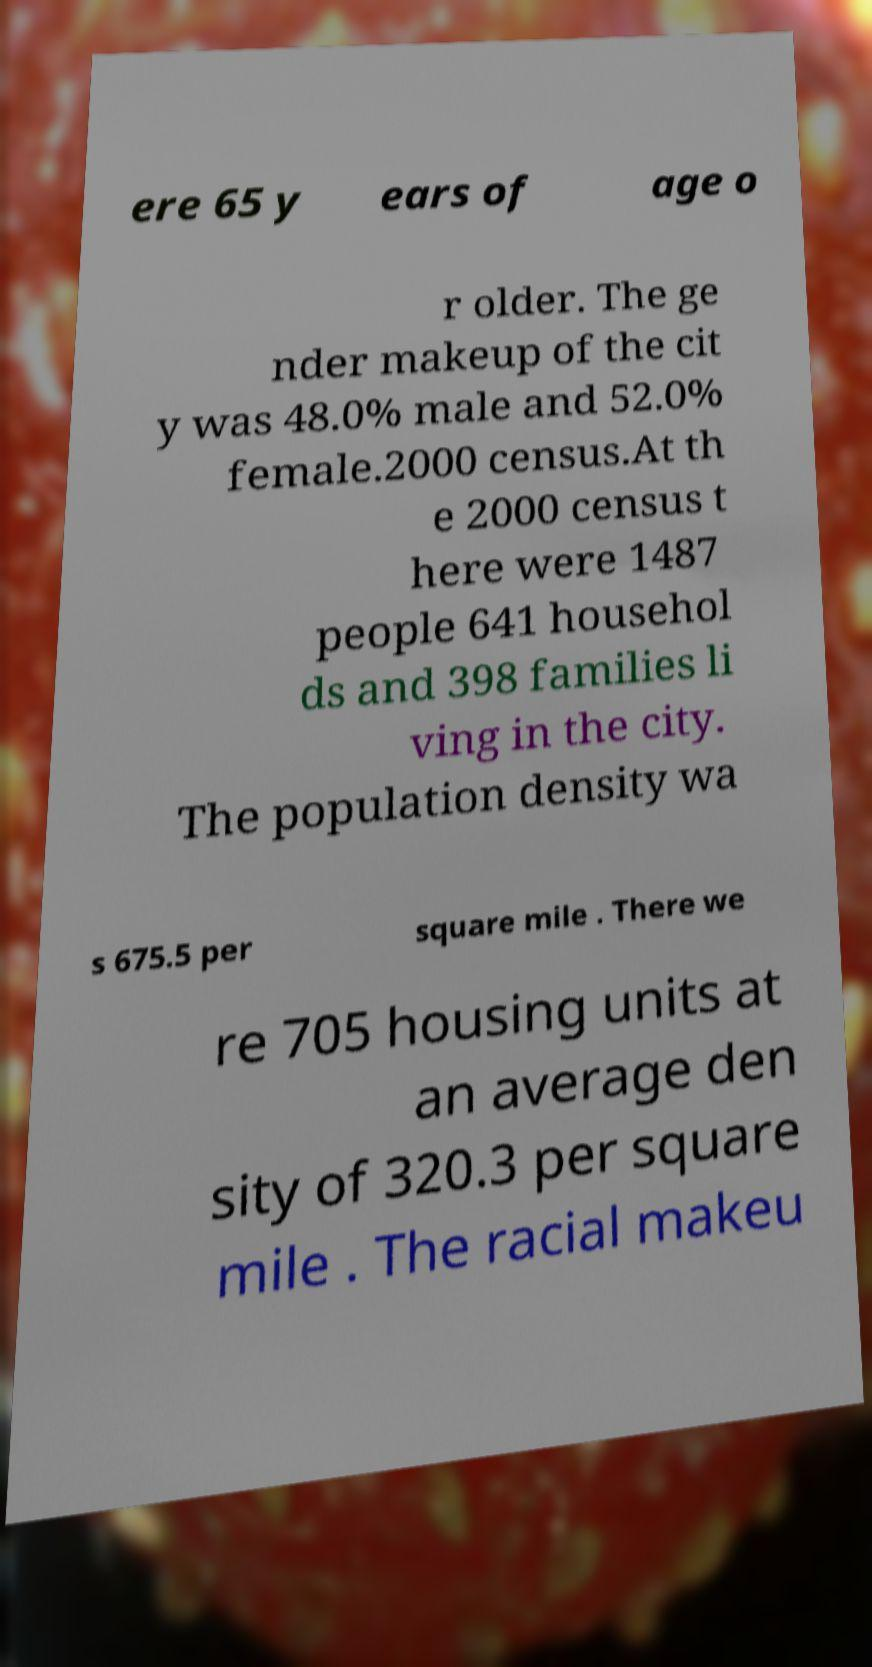Please read and relay the text visible in this image. What does it say? ere 65 y ears of age o r older. The ge nder makeup of the cit y was 48.0% male and 52.0% female.2000 census.At th e 2000 census t here were 1487 people 641 househol ds and 398 families li ving in the city. The population density wa s 675.5 per square mile . There we re 705 housing units at an average den sity of 320.3 per square mile . The racial makeu 